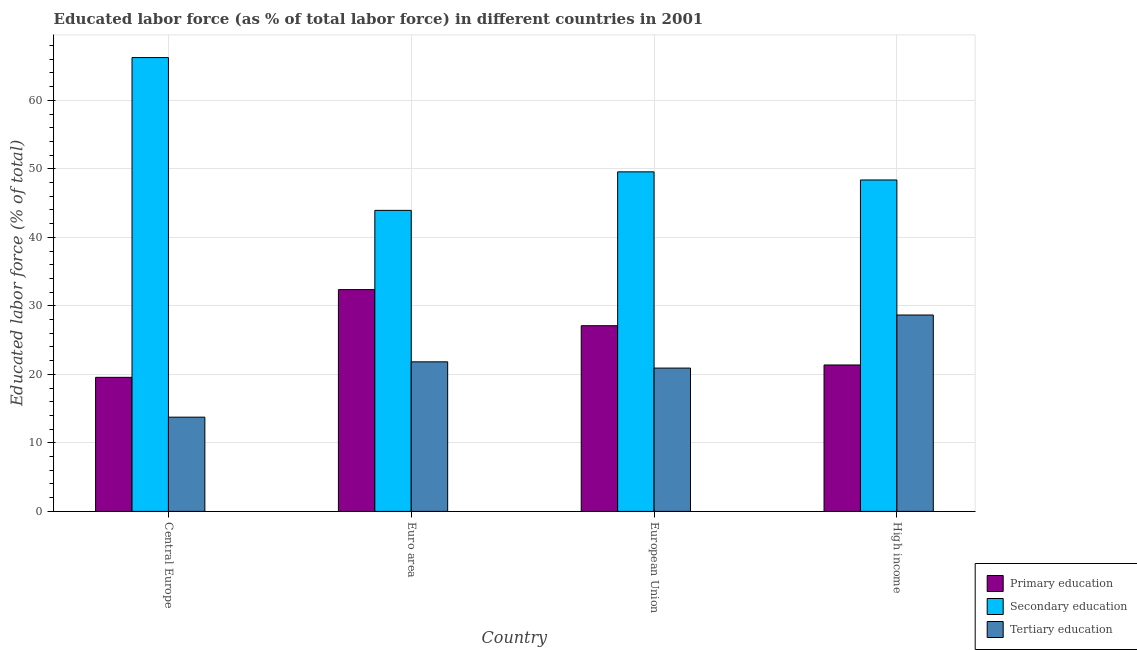How many groups of bars are there?
Offer a terse response. 4. What is the label of the 4th group of bars from the left?
Ensure brevity in your answer.  High income. In how many cases, is the number of bars for a given country not equal to the number of legend labels?
Provide a succinct answer. 0. What is the percentage of labor force who received tertiary education in Euro area?
Keep it short and to the point. 21.83. Across all countries, what is the maximum percentage of labor force who received tertiary education?
Make the answer very short. 28.66. Across all countries, what is the minimum percentage of labor force who received secondary education?
Your response must be concise. 43.94. In which country was the percentage of labor force who received tertiary education maximum?
Make the answer very short. High income. In which country was the percentage of labor force who received primary education minimum?
Keep it short and to the point. Central Europe. What is the total percentage of labor force who received tertiary education in the graph?
Your answer should be compact. 85.16. What is the difference between the percentage of labor force who received primary education in Central Europe and that in European Union?
Offer a terse response. -7.54. What is the difference between the percentage of labor force who received tertiary education in European Union and the percentage of labor force who received primary education in High income?
Your answer should be very brief. -0.45. What is the average percentage of labor force who received secondary education per country?
Offer a terse response. 52.03. What is the difference between the percentage of labor force who received primary education and percentage of labor force who received tertiary education in Central Europe?
Make the answer very short. 5.81. In how many countries, is the percentage of labor force who received tertiary education greater than 54 %?
Provide a short and direct response. 0. What is the ratio of the percentage of labor force who received secondary education in European Union to that in High income?
Your response must be concise. 1.02. Is the percentage of labor force who received primary education in Central Europe less than that in Euro area?
Offer a very short reply. Yes. What is the difference between the highest and the second highest percentage of labor force who received tertiary education?
Your answer should be very brief. 6.83. What is the difference between the highest and the lowest percentage of labor force who received primary education?
Ensure brevity in your answer.  12.81. In how many countries, is the percentage of labor force who received secondary education greater than the average percentage of labor force who received secondary education taken over all countries?
Provide a short and direct response. 1. What does the 2nd bar from the right in European Union represents?
Provide a short and direct response. Secondary education. Is it the case that in every country, the sum of the percentage of labor force who received primary education and percentage of labor force who received secondary education is greater than the percentage of labor force who received tertiary education?
Provide a succinct answer. Yes. How many countries are there in the graph?
Give a very brief answer. 4. Are the values on the major ticks of Y-axis written in scientific E-notation?
Offer a terse response. No. Does the graph contain any zero values?
Give a very brief answer. No. Where does the legend appear in the graph?
Give a very brief answer. Bottom right. How many legend labels are there?
Your answer should be very brief. 3. What is the title of the graph?
Give a very brief answer. Educated labor force (as % of total labor force) in different countries in 2001. Does "Taxes" appear as one of the legend labels in the graph?
Your answer should be compact. No. What is the label or title of the Y-axis?
Your answer should be compact. Educated labor force (% of total). What is the Educated labor force (% of total) in Primary education in Central Europe?
Your response must be concise. 19.56. What is the Educated labor force (% of total) of Secondary education in Central Europe?
Your answer should be very brief. 66.24. What is the Educated labor force (% of total) in Tertiary education in Central Europe?
Provide a short and direct response. 13.75. What is the Educated labor force (% of total) in Primary education in Euro area?
Make the answer very short. 32.37. What is the Educated labor force (% of total) of Secondary education in Euro area?
Offer a terse response. 43.94. What is the Educated labor force (% of total) in Tertiary education in Euro area?
Give a very brief answer. 21.83. What is the Educated labor force (% of total) of Primary education in European Union?
Offer a terse response. 27.1. What is the Educated labor force (% of total) in Secondary education in European Union?
Your response must be concise. 49.56. What is the Educated labor force (% of total) of Tertiary education in European Union?
Your answer should be compact. 20.92. What is the Educated labor force (% of total) in Primary education in High income?
Give a very brief answer. 21.37. What is the Educated labor force (% of total) of Secondary education in High income?
Provide a succinct answer. 48.37. What is the Educated labor force (% of total) in Tertiary education in High income?
Your answer should be very brief. 28.66. Across all countries, what is the maximum Educated labor force (% of total) of Primary education?
Offer a terse response. 32.37. Across all countries, what is the maximum Educated labor force (% of total) in Secondary education?
Provide a short and direct response. 66.24. Across all countries, what is the maximum Educated labor force (% of total) in Tertiary education?
Ensure brevity in your answer.  28.66. Across all countries, what is the minimum Educated labor force (% of total) of Primary education?
Keep it short and to the point. 19.56. Across all countries, what is the minimum Educated labor force (% of total) in Secondary education?
Keep it short and to the point. 43.94. Across all countries, what is the minimum Educated labor force (% of total) in Tertiary education?
Offer a very short reply. 13.75. What is the total Educated labor force (% of total) of Primary education in the graph?
Ensure brevity in your answer.  100.41. What is the total Educated labor force (% of total) in Secondary education in the graph?
Your answer should be very brief. 208.1. What is the total Educated labor force (% of total) in Tertiary education in the graph?
Offer a terse response. 85.16. What is the difference between the Educated labor force (% of total) in Primary education in Central Europe and that in Euro area?
Offer a very short reply. -12.81. What is the difference between the Educated labor force (% of total) of Secondary education in Central Europe and that in Euro area?
Provide a succinct answer. 22.3. What is the difference between the Educated labor force (% of total) in Tertiary education in Central Europe and that in Euro area?
Your answer should be very brief. -8.08. What is the difference between the Educated labor force (% of total) in Primary education in Central Europe and that in European Union?
Your answer should be very brief. -7.54. What is the difference between the Educated labor force (% of total) of Secondary education in Central Europe and that in European Union?
Offer a terse response. 16.68. What is the difference between the Educated labor force (% of total) of Tertiary education in Central Europe and that in European Union?
Your answer should be very brief. -7.16. What is the difference between the Educated labor force (% of total) of Primary education in Central Europe and that in High income?
Offer a terse response. -1.81. What is the difference between the Educated labor force (% of total) of Secondary education in Central Europe and that in High income?
Offer a very short reply. 17.87. What is the difference between the Educated labor force (% of total) in Tertiary education in Central Europe and that in High income?
Keep it short and to the point. -14.91. What is the difference between the Educated labor force (% of total) of Primary education in Euro area and that in European Union?
Your response must be concise. 5.27. What is the difference between the Educated labor force (% of total) in Secondary education in Euro area and that in European Union?
Keep it short and to the point. -5.62. What is the difference between the Educated labor force (% of total) in Tertiary education in Euro area and that in European Union?
Make the answer very short. 0.91. What is the difference between the Educated labor force (% of total) in Primary education in Euro area and that in High income?
Offer a terse response. 11. What is the difference between the Educated labor force (% of total) in Secondary education in Euro area and that in High income?
Offer a terse response. -4.44. What is the difference between the Educated labor force (% of total) of Tertiary education in Euro area and that in High income?
Provide a succinct answer. -6.83. What is the difference between the Educated labor force (% of total) in Primary education in European Union and that in High income?
Give a very brief answer. 5.73. What is the difference between the Educated labor force (% of total) in Secondary education in European Union and that in High income?
Ensure brevity in your answer.  1.19. What is the difference between the Educated labor force (% of total) of Tertiary education in European Union and that in High income?
Your answer should be compact. -7.75. What is the difference between the Educated labor force (% of total) in Primary education in Central Europe and the Educated labor force (% of total) in Secondary education in Euro area?
Keep it short and to the point. -24.37. What is the difference between the Educated labor force (% of total) of Primary education in Central Europe and the Educated labor force (% of total) of Tertiary education in Euro area?
Provide a succinct answer. -2.27. What is the difference between the Educated labor force (% of total) of Secondary education in Central Europe and the Educated labor force (% of total) of Tertiary education in Euro area?
Offer a very short reply. 44.41. What is the difference between the Educated labor force (% of total) in Primary education in Central Europe and the Educated labor force (% of total) in Secondary education in European Union?
Provide a short and direct response. -29.99. What is the difference between the Educated labor force (% of total) in Primary education in Central Europe and the Educated labor force (% of total) in Tertiary education in European Union?
Give a very brief answer. -1.35. What is the difference between the Educated labor force (% of total) in Secondary education in Central Europe and the Educated labor force (% of total) in Tertiary education in European Union?
Your response must be concise. 45.32. What is the difference between the Educated labor force (% of total) of Primary education in Central Europe and the Educated labor force (% of total) of Secondary education in High income?
Ensure brevity in your answer.  -28.81. What is the difference between the Educated labor force (% of total) in Primary education in Central Europe and the Educated labor force (% of total) in Tertiary education in High income?
Provide a succinct answer. -9.1. What is the difference between the Educated labor force (% of total) of Secondary education in Central Europe and the Educated labor force (% of total) of Tertiary education in High income?
Ensure brevity in your answer.  37.57. What is the difference between the Educated labor force (% of total) in Primary education in Euro area and the Educated labor force (% of total) in Secondary education in European Union?
Your answer should be very brief. -17.19. What is the difference between the Educated labor force (% of total) in Primary education in Euro area and the Educated labor force (% of total) in Tertiary education in European Union?
Ensure brevity in your answer.  11.46. What is the difference between the Educated labor force (% of total) of Secondary education in Euro area and the Educated labor force (% of total) of Tertiary education in European Union?
Provide a succinct answer. 23.02. What is the difference between the Educated labor force (% of total) in Primary education in Euro area and the Educated labor force (% of total) in Secondary education in High income?
Provide a short and direct response. -16. What is the difference between the Educated labor force (% of total) in Primary education in Euro area and the Educated labor force (% of total) in Tertiary education in High income?
Offer a terse response. 3.71. What is the difference between the Educated labor force (% of total) in Secondary education in Euro area and the Educated labor force (% of total) in Tertiary education in High income?
Ensure brevity in your answer.  15.27. What is the difference between the Educated labor force (% of total) in Primary education in European Union and the Educated labor force (% of total) in Secondary education in High income?
Your response must be concise. -21.27. What is the difference between the Educated labor force (% of total) in Primary education in European Union and the Educated labor force (% of total) in Tertiary education in High income?
Offer a very short reply. -1.56. What is the difference between the Educated labor force (% of total) in Secondary education in European Union and the Educated labor force (% of total) in Tertiary education in High income?
Your answer should be very brief. 20.9. What is the average Educated labor force (% of total) in Primary education per country?
Ensure brevity in your answer.  25.1. What is the average Educated labor force (% of total) of Secondary education per country?
Offer a terse response. 52.03. What is the average Educated labor force (% of total) in Tertiary education per country?
Provide a short and direct response. 21.29. What is the difference between the Educated labor force (% of total) of Primary education and Educated labor force (% of total) of Secondary education in Central Europe?
Your response must be concise. -46.67. What is the difference between the Educated labor force (% of total) of Primary education and Educated labor force (% of total) of Tertiary education in Central Europe?
Ensure brevity in your answer.  5.81. What is the difference between the Educated labor force (% of total) in Secondary education and Educated labor force (% of total) in Tertiary education in Central Europe?
Your answer should be compact. 52.48. What is the difference between the Educated labor force (% of total) of Primary education and Educated labor force (% of total) of Secondary education in Euro area?
Keep it short and to the point. -11.57. What is the difference between the Educated labor force (% of total) of Primary education and Educated labor force (% of total) of Tertiary education in Euro area?
Ensure brevity in your answer.  10.54. What is the difference between the Educated labor force (% of total) of Secondary education and Educated labor force (% of total) of Tertiary education in Euro area?
Provide a short and direct response. 22.11. What is the difference between the Educated labor force (% of total) in Primary education and Educated labor force (% of total) in Secondary education in European Union?
Make the answer very short. -22.46. What is the difference between the Educated labor force (% of total) of Primary education and Educated labor force (% of total) of Tertiary education in European Union?
Provide a short and direct response. 6.19. What is the difference between the Educated labor force (% of total) in Secondary education and Educated labor force (% of total) in Tertiary education in European Union?
Your response must be concise. 28.64. What is the difference between the Educated labor force (% of total) of Primary education and Educated labor force (% of total) of Secondary education in High income?
Offer a terse response. -27. What is the difference between the Educated labor force (% of total) of Primary education and Educated labor force (% of total) of Tertiary education in High income?
Offer a very short reply. -7.29. What is the difference between the Educated labor force (% of total) in Secondary education and Educated labor force (% of total) in Tertiary education in High income?
Offer a terse response. 19.71. What is the ratio of the Educated labor force (% of total) in Primary education in Central Europe to that in Euro area?
Offer a terse response. 0.6. What is the ratio of the Educated labor force (% of total) of Secondary education in Central Europe to that in Euro area?
Make the answer very short. 1.51. What is the ratio of the Educated labor force (% of total) of Tertiary education in Central Europe to that in Euro area?
Provide a succinct answer. 0.63. What is the ratio of the Educated labor force (% of total) of Primary education in Central Europe to that in European Union?
Give a very brief answer. 0.72. What is the ratio of the Educated labor force (% of total) in Secondary education in Central Europe to that in European Union?
Offer a terse response. 1.34. What is the ratio of the Educated labor force (% of total) of Tertiary education in Central Europe to that in European Union?
Make the answer very short. 0.66. What is the ratio of the Educated labor force (% of total) of Primary education in Central Europe to that in High income?
Provide a short and direct response. 0.92. What is the ratio of the Educated labor force (% of total) in Secondary education in Central Europe to that in High income?
Ensure brevity in your answer.  1.37. What is the ratio of the Educated labor force (% of total) in Tertiary education in Central Europe to that in High income?
Ensure brevity in your answer.  0.48. What is the ratio of the Educated labor force (% of total) of Primary education in Euro area to that in European Union?
Provide a succinct answer. 1.19. What is the ratio of the Educated labor force (% of total) in Secondary education in Euro area to that in European Union?
Your answer should be compact. 0.89. What is the ratio of the Educated labor force (% of total) in Tertiary education in Euro area to that in European Union?
Your response must be concise. 1.04. What is the ratio of the Educated labor force (% of total) in Primary education in Euro area to that in High income?
Keep it short and to the point. 1.51. What is the ratio of the Educated labor force (% of total) in Secondary education in Euro area to that in High income?
Offer a terse response. 0.91. What is the ratio of the Educated labor force (% of total) of Tertiary education in Euro area to that in High income?
Make the answer very short. 0.76. What is the ratio of the Educated labor force (% of total) of Primary education in European Union to that in High income?
Keep it short and to the point. 1.27. What is the ratio of the Educated labor force (% of total) in Secondary education in European Union to that in High income?
Provide a succinct answer. 1.02. What is the ratio of the Educated labor force (% of total) in Tertiary education in European Union to that in High income?
Your answer should be very brief. 0.73. What is the difference between the highest and the second highest Educated labor force (% of total) of Primary education?
Your response must be concise. 5.27. What is the difference between the highest and the second highest Educated labor force (% of total) of Secondary education?
Your answer should be very brief. 16.68. What is the difference between the highest and the second highest Educated labor force (% of total) in Tertiary education?
Ensure brevity in your answer.  6.83. What is the difference between the highest and the lowest Educated labor force (% of total) of Primary education?
Your answer should be very brief. 12.81. What is the difference between the highest and the lowest Educated labor force (% of total) in Secondary education?
Make the answer very short. 22.3. What is the difference between the highest and the lowest Educated labor force (% of total) in Tertiary education?
Give a very brief answer. 14.91. 